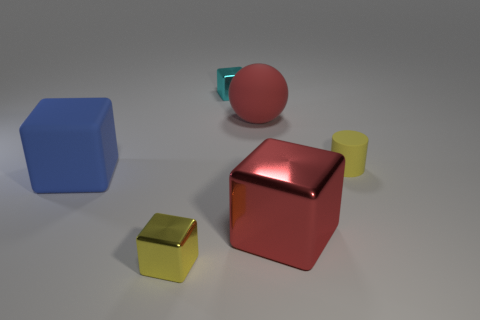Is the material of the blue cube the same as the yellow block?
Your answer should be very brief. No. There is a blue thing that is the same shape as the cyan thing; what is its size?
Make the answer very short. Large. How many other things are made of the same material as the large blue object?
Your answer should be compact. 2. Is there any other thing that has the same shape as the yellow matte thing?
Ensure brevity in your answer.  No. What is the color of the large object behind the tiny yellow object behind the big cube on the right side of the yellow shiny object?
Offer a terse response. Red. There is a shiny object that is in front of the tiny cyan shiny thing and on the left side of the red shiny cube; what is its shape?
Provide a succinct answer. Cube. What color is the large block that is to the left of the metal cube to the left of the small cyan metal cube?
Keep it short and to the point. Blue. There is a yellow object on the right side of the large rubber object that is right of the tiny yellow thing on the left side of the tiny yellow rubber thing; what is its shape?
Give a very brief answer. Cylinder. There is a metal cube that is both left of the big red shiny block and in front of the tiny rubber cylinder; what is its size?
Keep it short and to the point. Small. How many other big spheres are the same color as the big rubber ball?
Your answer should be compact. 0. 